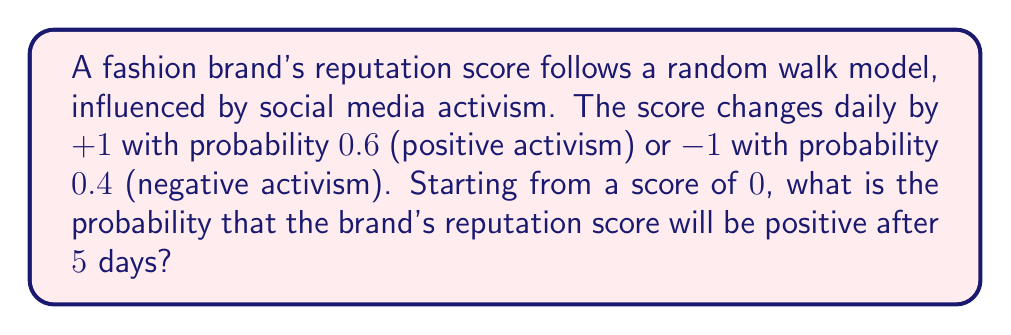Provide a solution to this math problem. Let's approach this step-by-step:

1) This scenario can be modeled as a binomial random walk. Each day, the score either increases by 1 (with probability 0.6) or decreases by 1 (with probability 0.4).

2) For the final score to be positive after 5 days, we need more increases than decreases. This can happen in the following ways:
   - 3 increases and 2 decreases
   - 4 increases and 1 decrease
   - 5 increases and 0 decreases

3) Let's calculate the probability of each scenario using the binomial probability formula:

   $$P(X=k) = \binom{n}{k} p^k (1-p)^{n-k}$$

   where $n$ is the number of trials, $k$ is the number of successes, $p$ is the probability of success.

4) For 3 increases and 2 decreases:
   $$P(3,2) = \binom{5}{3} (0.6)^3 (0.4)^2 = 10 \cdot 0.216 \cdot 0.16 = 0.3456$$

5) For 4 increases and 1 decrease:
   $$P(4,1) = \binom{5}{4} (0.6)^4 (0.4)^1 = 5 \cdot 0.1296 \cdot 0.4 = 0.2592$$

6) For 5 increases and 0 decreases:
   $$P(5,0) = \binom{5}{5} (0.6)^5 (0.4)^0 = 1 \cdot 0.07776 \cdot 1 = 0.07776$$

7) The total probability is the sum of these individual probabilities:
   $$P(\text{positive}) = 0.3456 + 0.2592 + 0.07776 = 0.68256$$
Answer: 0.68256 